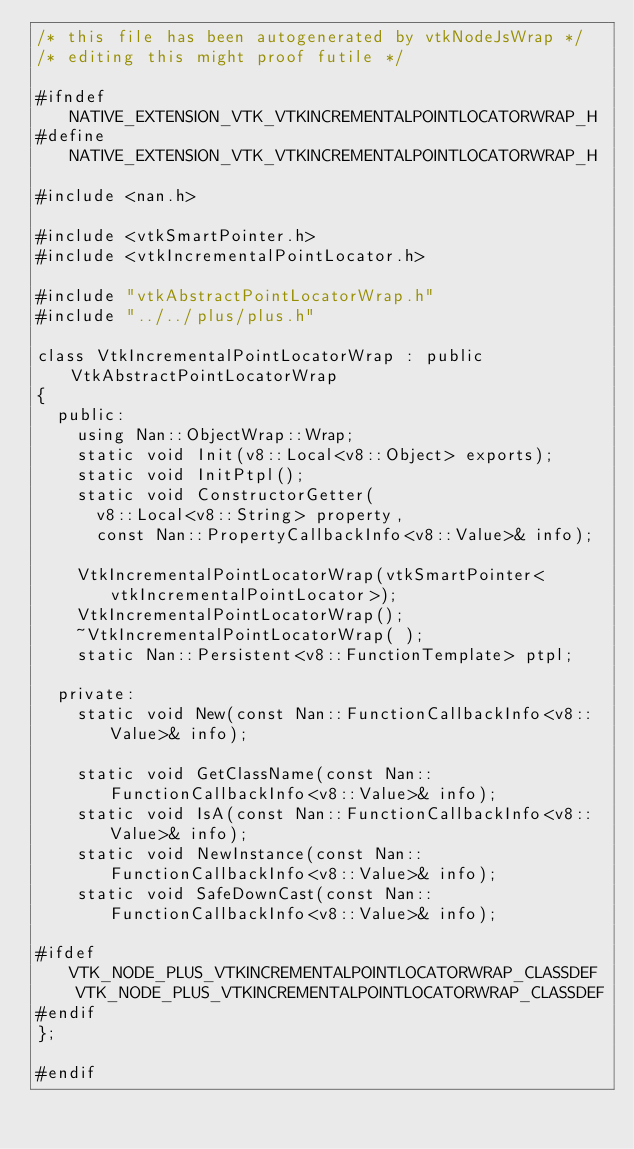Convert code to text. <code><loc_0><loc_0><loc_500><loc_500><_C_>/* this file has been autogenerated by vtkNodeJsWrap */
/* editing this might proof futile */

#ifndef NATIVE_EXTENSION_VTK_VTKINCREMENTALPOINTLOCATORWRAP_H
#define NATIVE_EXTENSION_VTK_VTKINCREMENTALPOINTLOCATORWRAP_H

#include <nan.h>

#include <vtkSmartPointer.h>
#include <vtkIncrementalPointLocator.h>

#include "vtkAbstractPointLocatorWrap.h"
#include "../../plus/plus.h"

class VtkIncrementalPointLocatorWrap : public VtkAbstractPointLocatorWrap
{
	public:
		using Nan::ObjectWrap::Wrap;
		static void Init(v8::Local<v8::Object> exports);
		static void InitPtpl();
		static void ConstructorGetter(
			v8::Local<v8::String> property,
			const Nan::PropertyCallbackInfo<v8::Value>& info);

		VtkIncrementalPointLocatorWrap(vtkSmartPointer<vtkIncrementalPointLocator>);
		VtkIncrementalPointLocatorWrap();
		~VtkIncrementalPointLocatorWrap( );
		static Nan::Persistent<v8::FunctionTemplate> ptpl;

	private:
		static void New(const Nan::FunctionCallbackInfo<v8::Value>& info);

		static void GetClassName(const Nan::FunctionCallbackInfo<v8::Value>& info);
		static void IsA(const Nan::FunctionCallbackInfo<v8::Value>& info);
		static void NewInstance(const Nan::FunctionCallbackInfo<v8::Value>& info);
		static void SafeDownCast(const Nan::FunctionCallbackInfo<v8::Value>& info);

#ifdef VTK_NODE_PLUS_VTKINCREMENTALPOINTLOCATORWRAP_CLASSDEF
		VTK_NODE_PLUS_VTKINCREMENTALPOINTLOCATORWRAP_CLASSDEF
#endif
};

#endif
</code> 